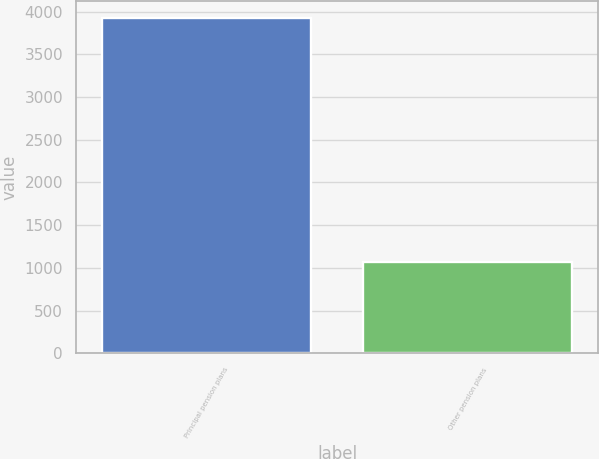Convert chart. <chart><loc_0><loc_0><loc_500><loc_500><bar_chart><fcel>Principal pension plans<fcel>Other pension plans<nl><fcel>3930<fcel>1070<nl></chart> 